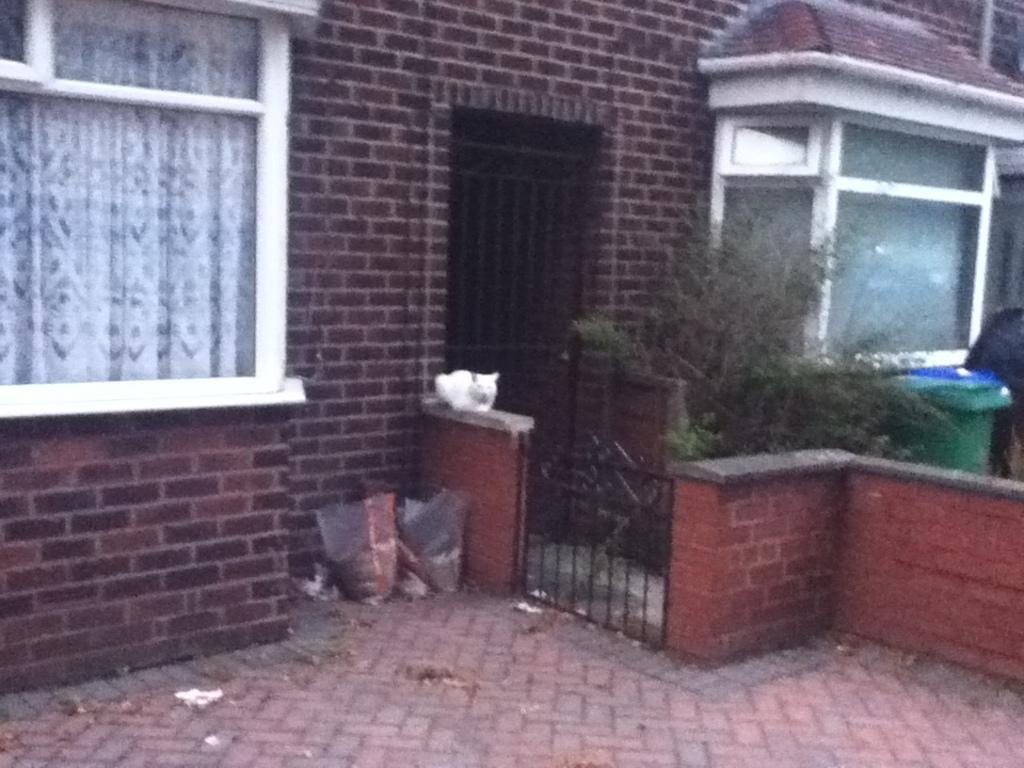In one or two sentences, can you explain what this image depicts? As we can see in the image there are houses, window, curtain, covers, plants and dustbin. 